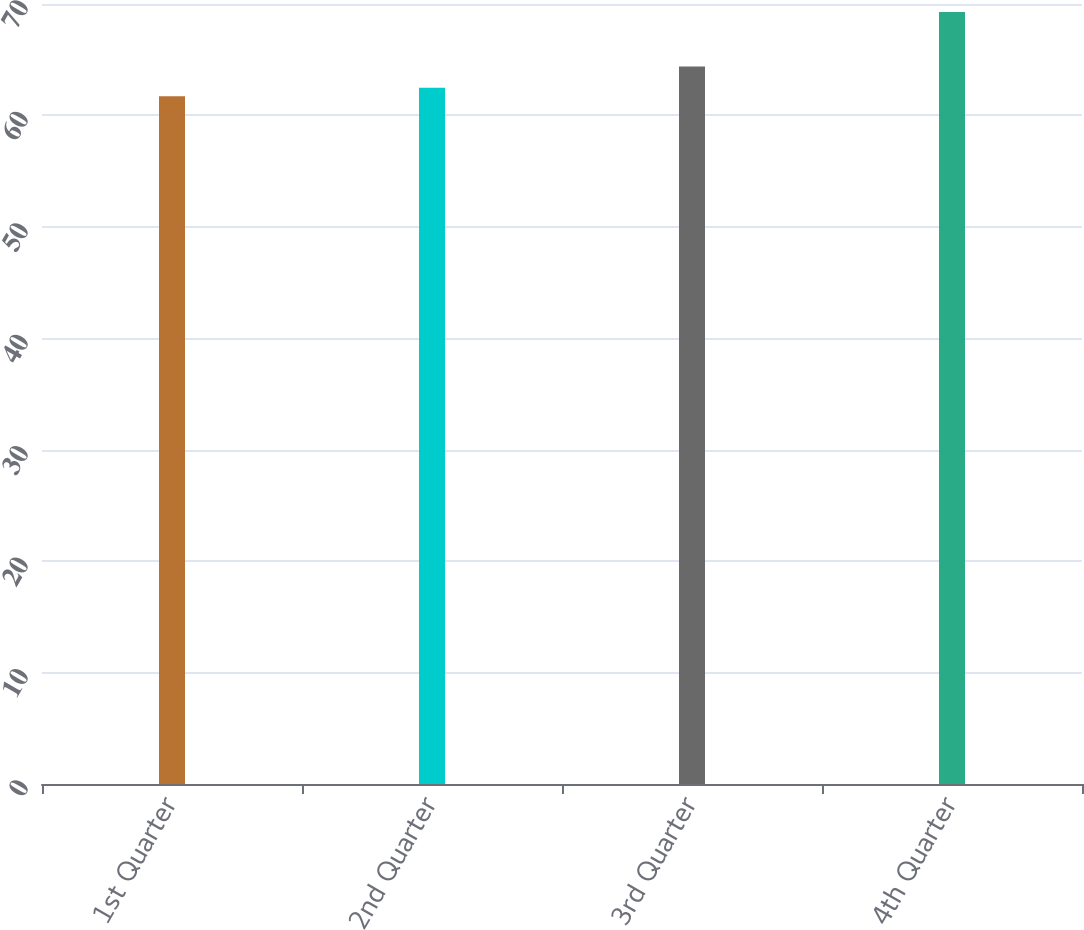<chart> <loc_0><loc_0><loc_500><loc_500><bar_chart><fcel>1st Quarter<fcel>2nd Quarter<fcel>3rd Quarter<fcel>4th Quarter<nl><fcel>61.72<fcel>62.48<fcel>64.38<fcel>69.29<nl></chart> 